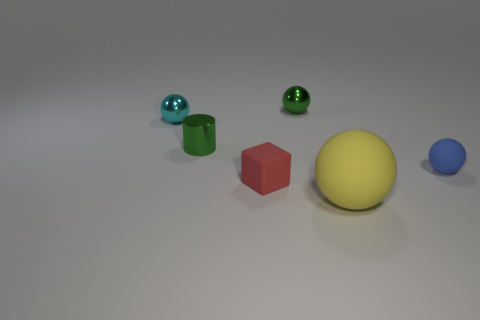Add 2 small cyan metal balls. How many objects exist? 8 Subtract all blocks. How many objects are left? 5 Subtract all small cyan metallic balls. Subtract all blue rubber objects. How many objects are left? 4 Add 1 small cyan things. How many small cyan things are left? 2 Add 5 small cyan cylinders. How many small cyan cylinders exist? 5 Subtract 0 blue cylinders. How many objects are left? 6 